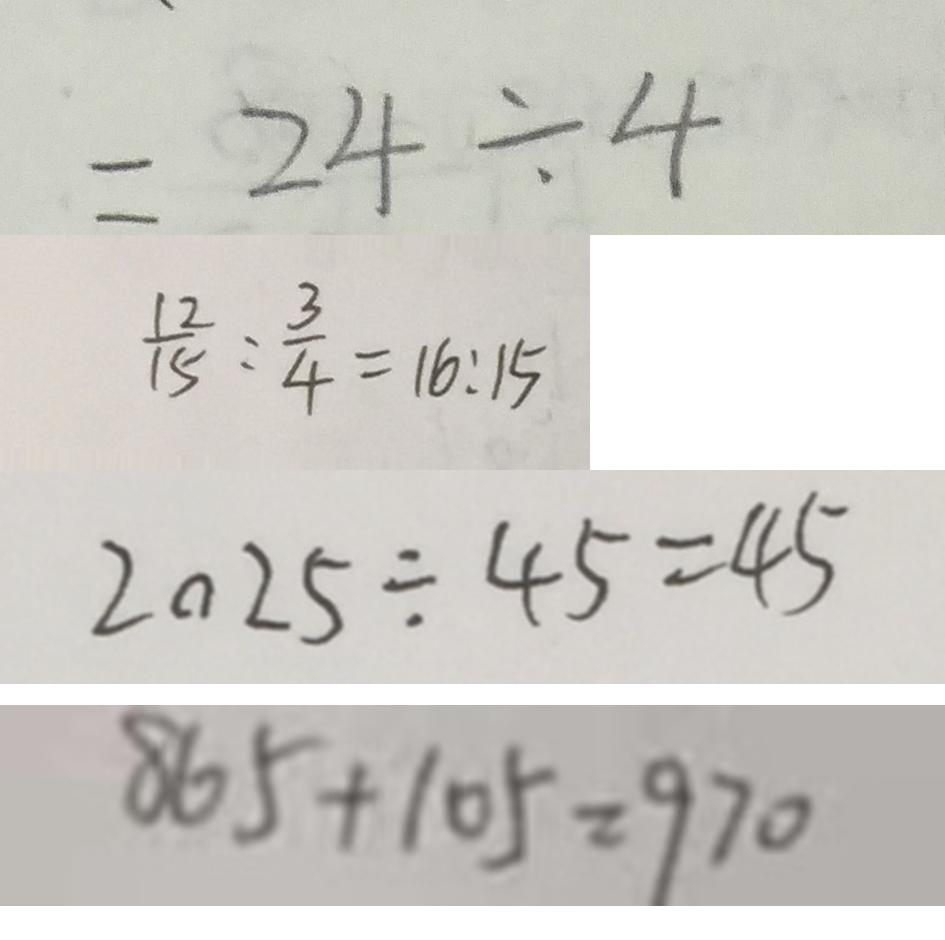<formula> <loc_0><loc_0><loc_500><loc_500>= 2 4 \div 4 
 \frac { 1 2 } { 1 5 } : \frac { 3 } { 4 } = 1 6 : 1 5 
 2 0 2 5 \div 4 5 = 4 5 
 8 6 5 + 1 0 5 = 9 7 0</formula> 